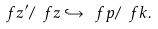<formula> <loc_0><loc_0><loc_500><loc_500>\ f z ^ { \prime } / \ f z \hookrightarrow \ f p / \ f k .</formula> 